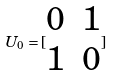<formula> <loc_0><loc_0><loc_500><loc_500>U _ { 0 } = [ \begin{matrix} 0 & 1 \\ 1 & 0 \end{matrix} ]</formula> 